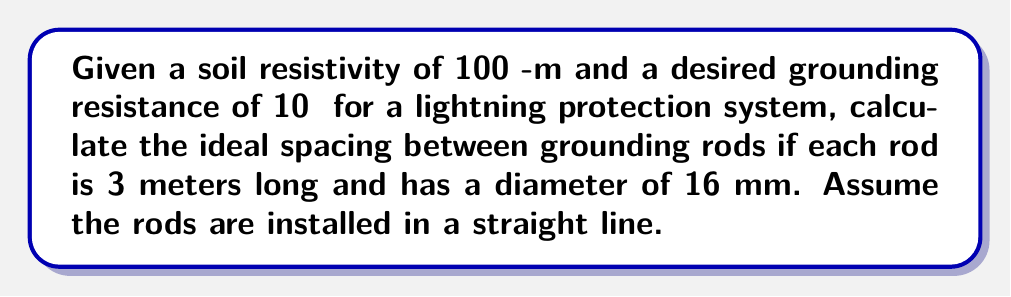Could you help me with this problem? To solve this problem, we'll use the Sverak's formula for multiple rod grounding systems:

$$R = \frac{\rho}{2\pi nL} \left(\ln\frac{4L}{a} + \ln\frac{4L}{s} - 1 + \frac{2K_1L}{\sqrt{A}} + \frac{K_2}{\sqrt{n}}\right)$$

Where:
$R$ = Grounding resistance (Ω)
$\rho$ = Soil resistivity (Ω-m)
$n$ = Number of rods
$L$ = Length of each rod (m)
$a$ = Rod diameter (m)
$s$ = Spacing between rods (m)
$A$ = Area covered by the grounding system (m²)
$K_1$ and $K_2$ are constants (use $K_1 = 1.43$ and $K_2 = 5.5$ for linear arrangements)

Step 1: Substitute known values
$R = 10$ Ω
$\rho = 100$ Ω-m
$L = 3$ m
$a = 0.016$ m

Step 2: Simplify the equation by assuming two rods ($n = 2$) and solving for $s$:

$$10 = \frac{100}{2\pi \cdot 2 \cdot 3} \left(\ln\frac{4 \cdot 3}{0.016} + \ln\frac{4 \cdot 3}{s} - 1 + \frac{2 \cdot 1.43 \cdot 3}{\sqrt{3s}} + \frac{5.5}{\sqrt{2}}\right)$$

Step 3: Simplify further:

$$10 = \frac{100}{12\pi} \left(11.52 + \ln\frac{12}{s} + 7.44 + 3.89\right)$$

Step 4: Solve for $s$ using numerical methods or graphing software:

$$s \approx 5.8 \text{ m}$$

Therefore, the ideal spacing between grounding rods is approximately 5.8 meters.
Answer: 5.8 m 